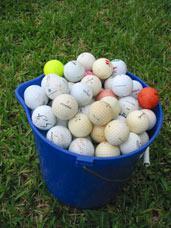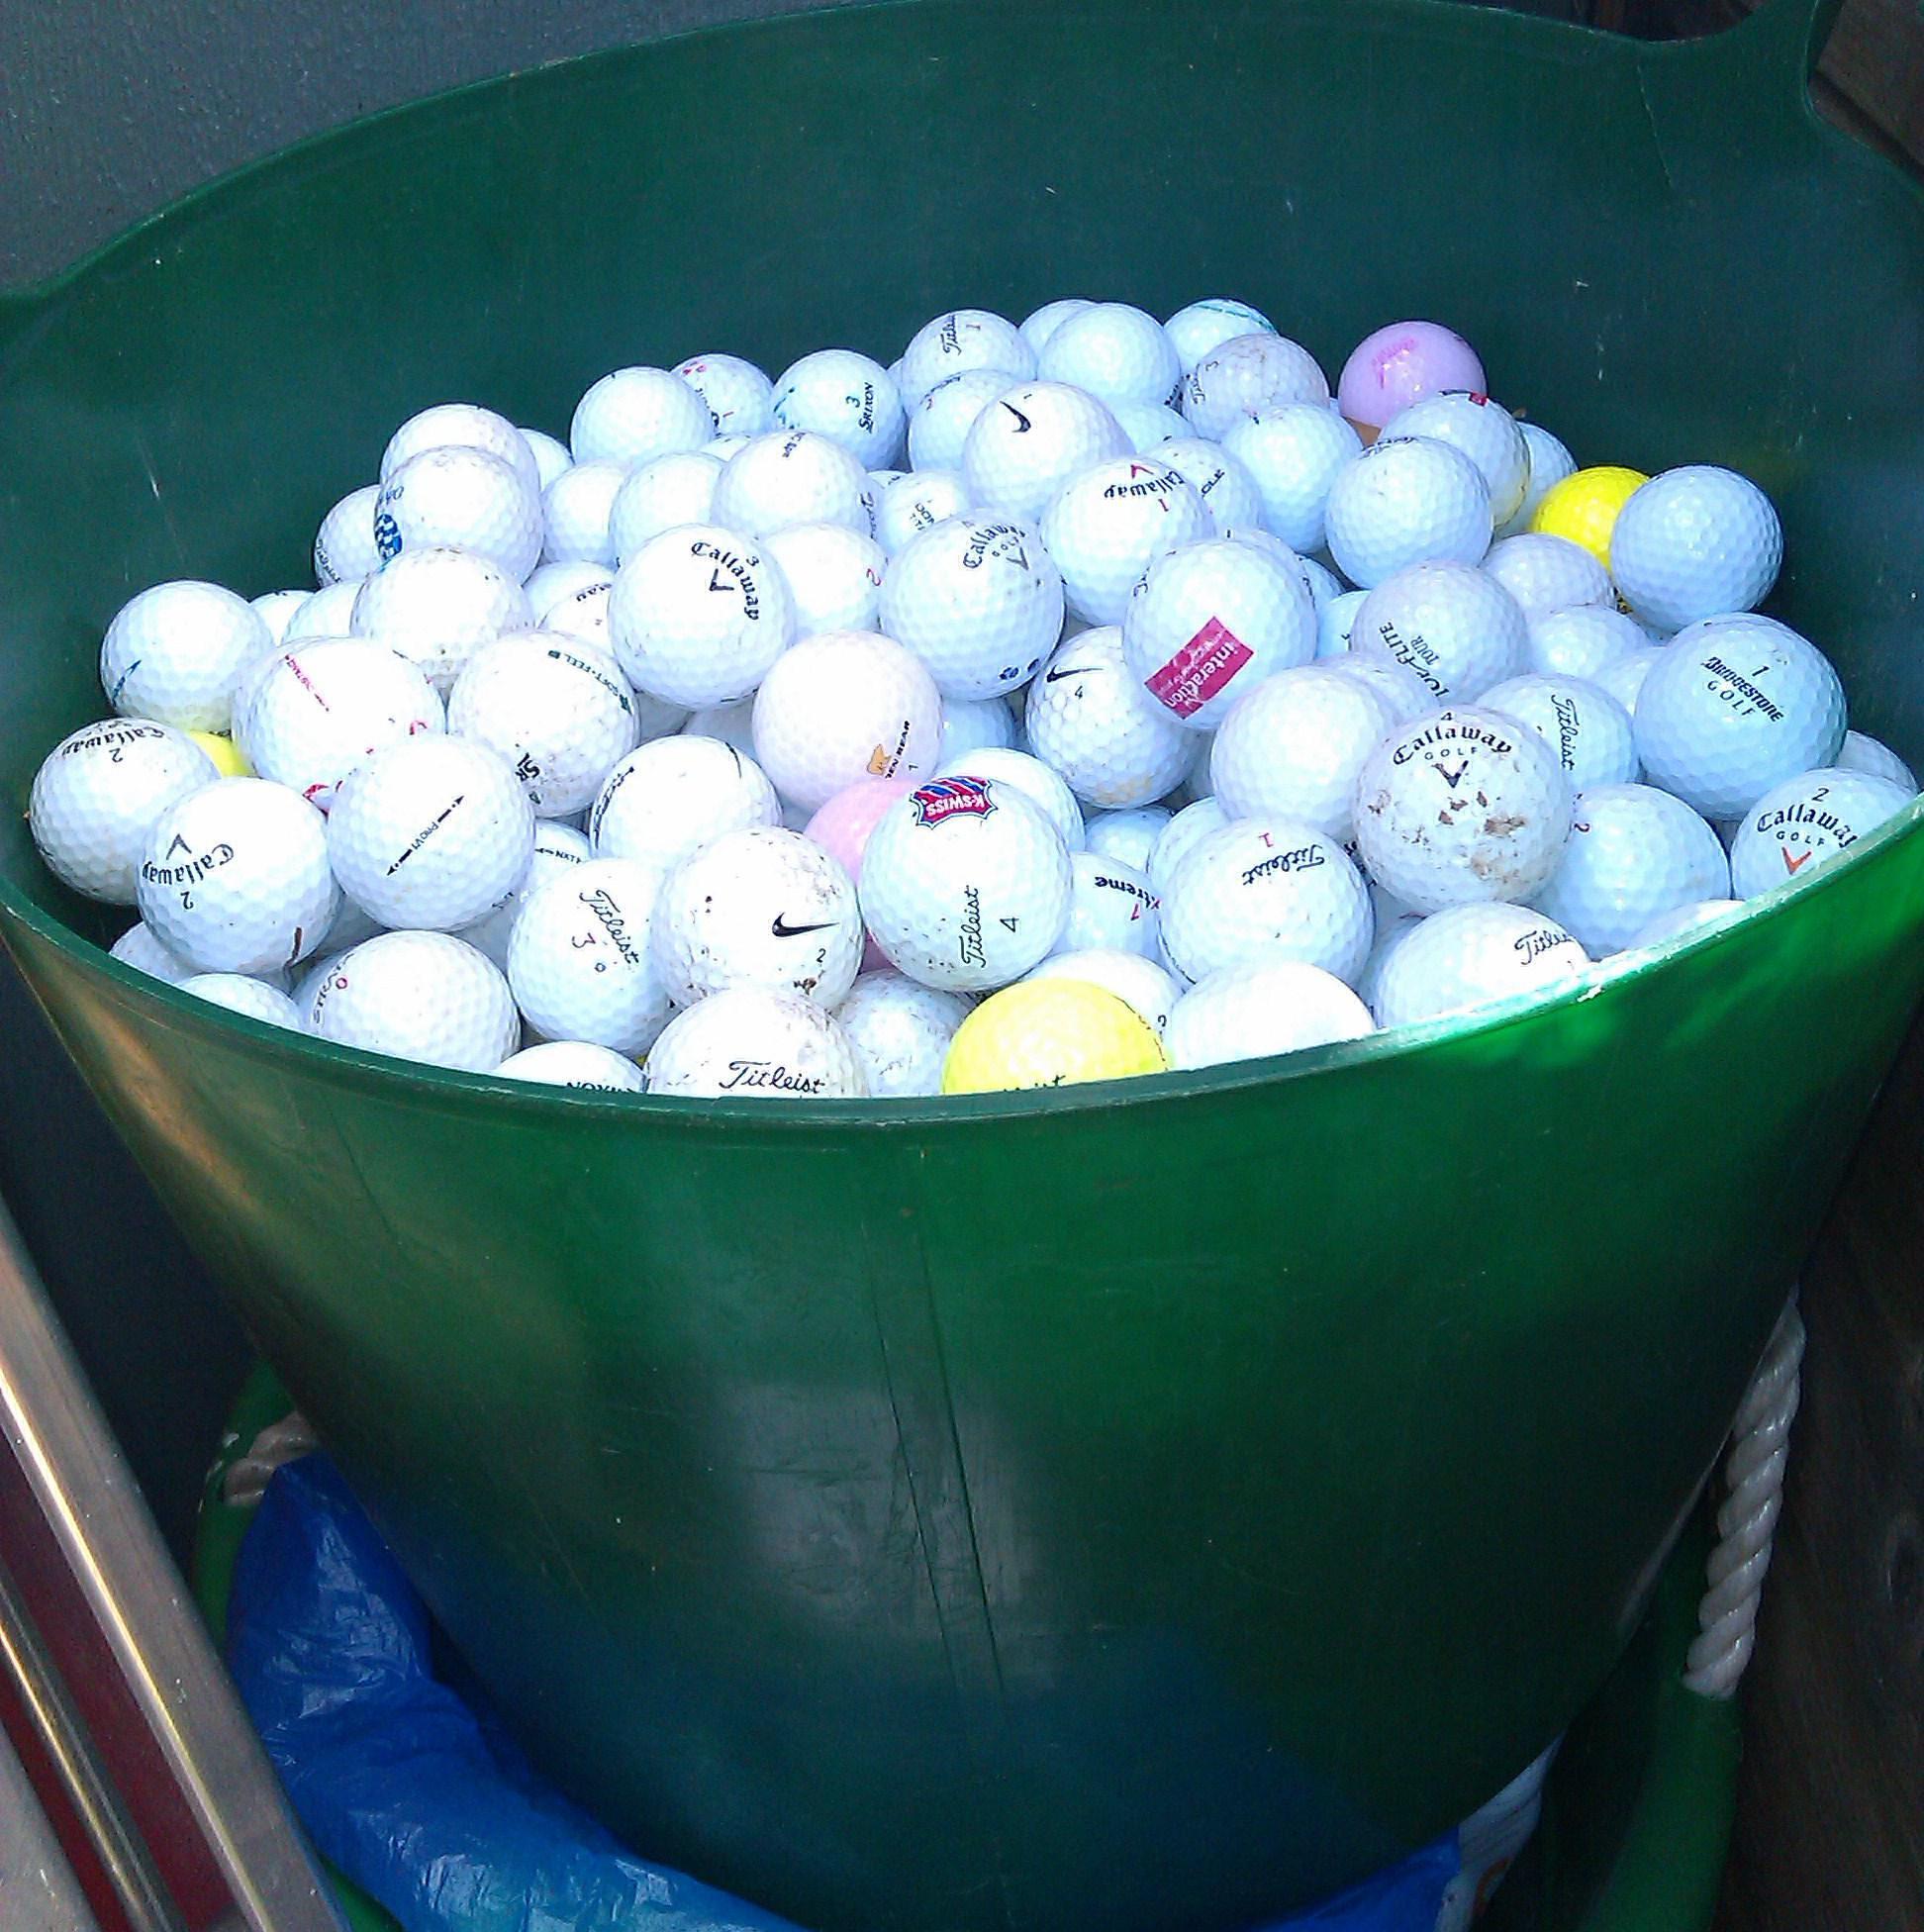The first image is the image on the left, the second image is the image on the right. Analyze the images presented: Is the assertion "There is a red golf ball in the pile." valid? Answer yes or no. Yes. The first image is the image on the left, the second image is the image on the right. Assess this claim about the two images: "In 1 of the images, at least 1 bucket is tipped over.". Correct or not? Answer yes or no. No. 